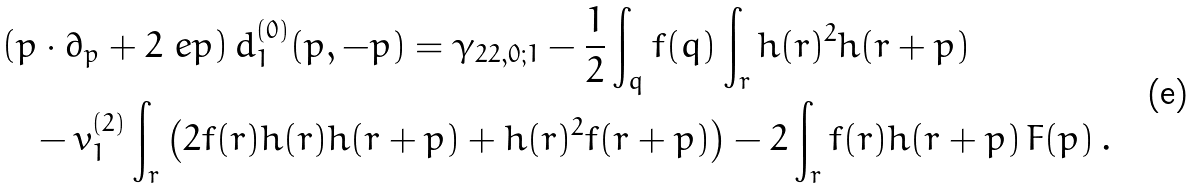<formula> <loc_0><loc_0><loc_500><loc_500>& \left ( p \cdot \partial _ { p } + 2 \ e p \right ) d ^ { ( 0 ) } _ { 1 } ( p , - p ) = \gamma _ { 2 2 , 0 ; 1 } - \frac { 1 } { 2 } \int _ { q } f ( q ) \int _ { r } h ( r ) ^ { 2 } h ( r + p ) \\ & \quad - v _ { 1 } ^ { ( 2 ) } \int _ { r } \left ( 2 f ( r ) h ( r ) h ( r + p ) + h ( r ) ^ { 2 } f ( r + p ) \right ) - 2 \int _ { r } f ( r ) h ( r + p ) \, F ( p ) \, .</formula> 